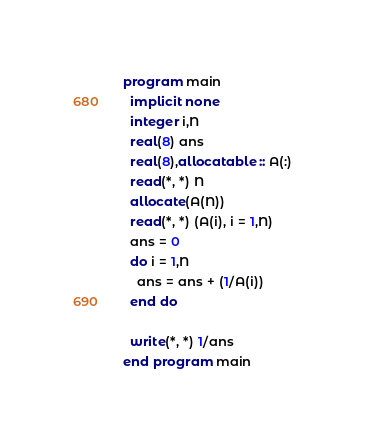Convert code to text. <code><loc_0><loc_0><loc_500><loc_500><_FORTRAN_>program main
  implicit none
  integer i,N
  real(8) ans
  real(8),allocatable :: A(:)
  read(*, *) N
  allocate(A(N))
  read(*, *) (A(i), i = 1,N)
  ans = 0
  do i = 1,N
    ans = ans + (1/A(i))
  end do

  write(*, *) 1/ans
end program main
</code> 